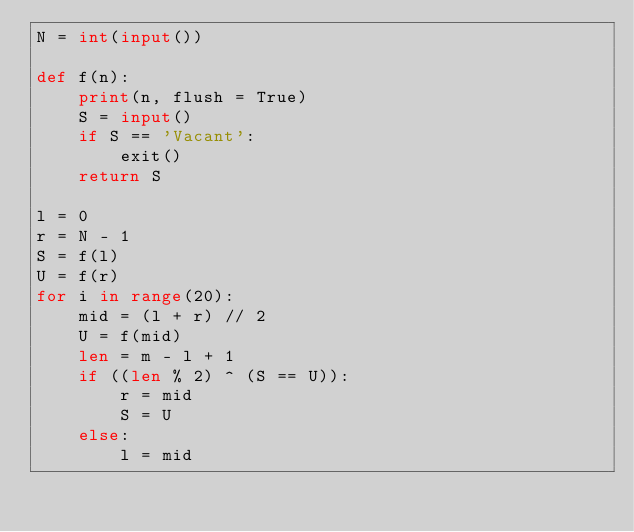<code> <loc_0><loc_0><loc_500><loc_500><_Python_>N = int(input())

def f(n):
    print(n, flush = True)
    S = input()
    if S == 'Vacant':
        exit()
    return S

l = 0
r = N - 1
S = f(l)
U = f(r)
for i in range(20):
    mid = (l + r) // 2
    U = f(mid)
    len = m - l + 1
    if ((len % 2) ^ (S == U)):
        r = mid
        S = U
    else:
        l = mid
</code> 